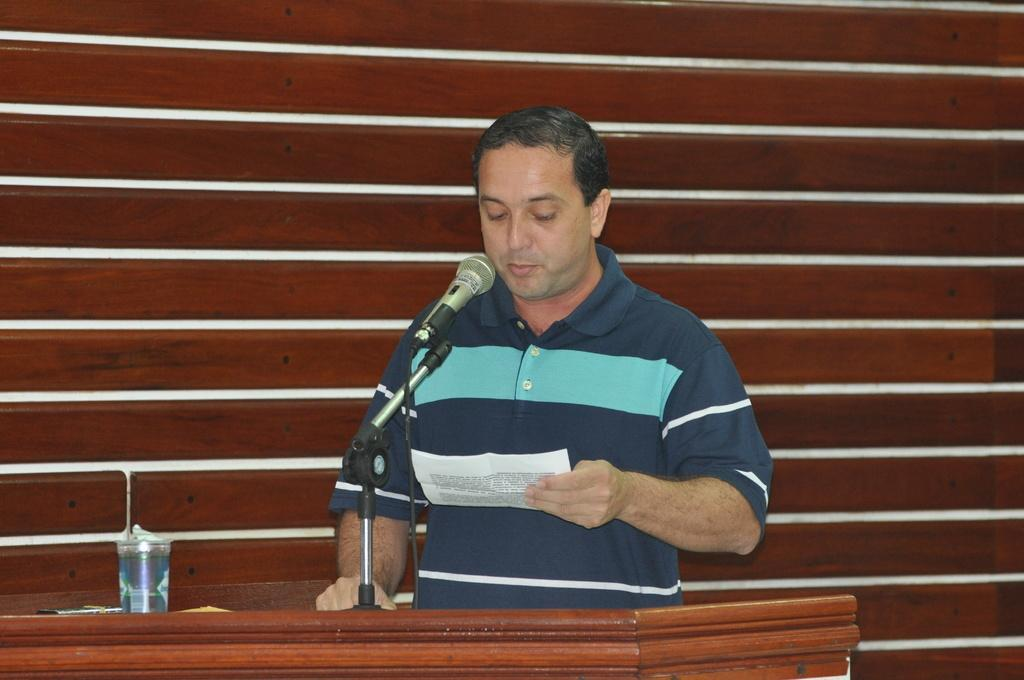Who is present in the image? There is a man in the image. What is the man holding in the image? The man is holding a paper. What is the man doing with the paper? The man is looking at the paper. What objects are on the table in the image? There is a mic and a glass on the table. What type of science is being discussed in the image? There is no indication of any scientific discussion in the image. 